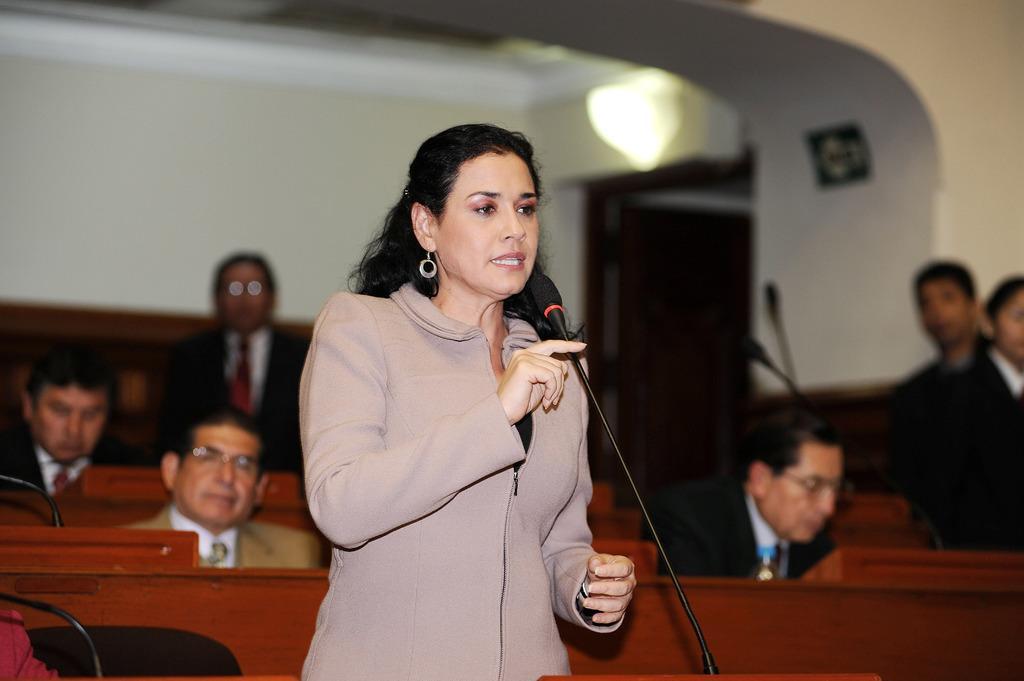How would you summarize this image in a sentence or two? In the picture we can see a woman standing and talking into the microphone and behind her we can see some people are sitting near the desk and few people are standing, and behind them we can see the door and top of it we can see the light. 